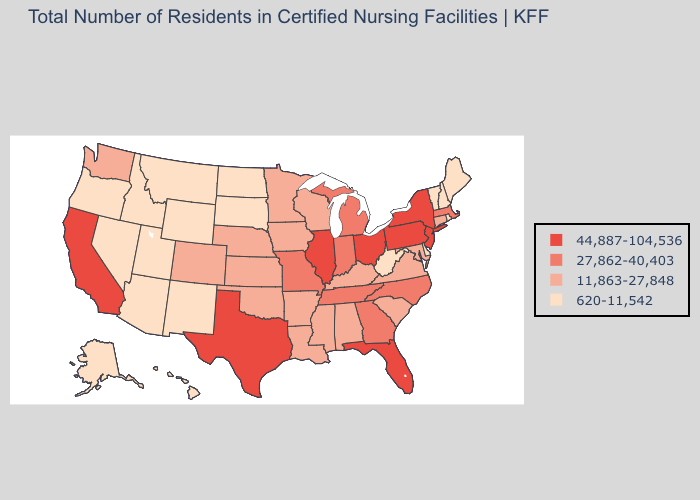What is the lowest value in the South?
Concise answer only. 620-11,542. Which states have the highest value in the USA?
Write a very short answer. California, Florida, Illinois, New Jersey, New York, Ohio, Pennsylvania, Texas. What is the highest value in states that border New York?
Keep it brief. 44,887-104,536. Name the states that have a value in the range 44,887-104,536?
Short answer required. California, Florida, Illinois, New Jersey, New York, Ohio, Pennsylvania, Texas. Does Florida have a higher value than New York?
Give a very brief answer. No. Name the states that have a value in the range 27,862-40,403?
Quick response, please. Georgia, Indiana, Massachusetts, Michigan, Missouri, North Carolina, Tennessee. What is the value of Indiana?
Write a very short answer. 27,862-40,403. Does Delaware have the lowest value in the South?
Answer briefly. Yes. Name the states that have a value in the range 620-11,542?
Keep it brief. Alaska, Arizona, Delaware, Hawaii, Idaho, Maine, Montana, Nevada, New Hampshire, New Mexico, North Dakota, Oregon, Rhode Island, South Dakota, Utah, Vermont, West Virginia, Wyoming. What is the highest value in the USA?
Write a very short answer. 44,887-104,536. What is the lowest value in the South?
Answer briefly. 620-11,542. What is the value of Nebraska?
Quick response, please. 11,863-27,848. What is the value of Arizona?
Answer briefly. 620-11,542. What is the value of Arkansas?
Concise answer only. 11,863-27,848. Among the states that border Wisconsin , which have the highest value?
Quick response, please. Illinois. 